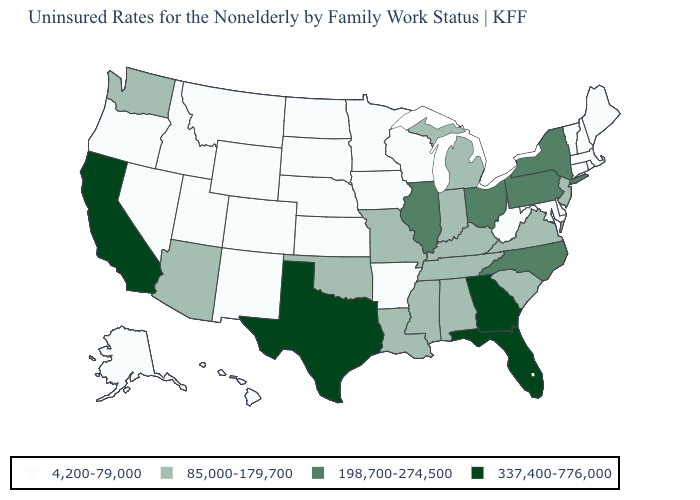How many symbols are there in the legend?
Short answer required. 4. Does Nebraska have the lowest value in the USA?
Answer briefly. Yes. What is the value of Virginia?
Give a very brief answer. 85,000-179,700. How many symbols are there in the legend?
Give a very brief answer. 4. Does Alaska have the same value as Nevada?
Give a very brief answer. Yes. Name the states that have a value in the range 198,700-274,500?
Be succinct. Illinois, New York, North Carolina, Ohio, Pennsylvania. Does Maine have a higher value than South Carolina?
Quick response, please. No. Name the states that have a value in the range 4,200-79,000?
Answer briefly. Alaska, Arkansas, Colorado, Connecticut, Delaware, Hawaii, Idaho, Iowa, Kansas, Maine, Maryland, Massachusetts, Minnesota, Montana, Nebraska, Nevada, New Hampshire, New Mexico, North Dakota, Oregon, Rhode Island, South Dakota, Utah, Vermont, West Virginia, Wisconsin, Wyoming. What is the lowest value in states that border Minnesota?
Write a very short answer. 4,200-79,000. Among the states that border North Dakota , which have the highest value?
Answer briefly. Minnesota, Montana, South Dakota. What is the value of West Virginia?
Give a very brief answer. 4,200-79,000. Name the states that have a value in the range 337,400-776,000?
Be succinct. California, Florida, Georgia, Texas. Which states have the lowest value in the MidWest?
Give a very brief answer. Iowa, Kansas, Minnesota, Nebraska, North Dakota, South Dakota, Wisconsin. What is the lowest value in the USA?
Give a very brief answer. 4,200-79,000. 